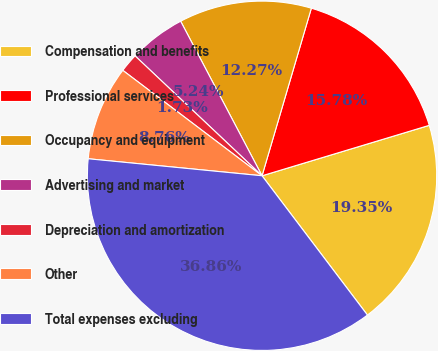Convert chart. <chart><loc_0><loc_0><loc_500><loc_500><pie_chart><fcel>Compensation and benefits<fcel>Professional services<fcel>Occupancy and equipment<fcel>Advertising and market<fcel>Depreciation and amortization<fcel>Other<fcel>Total expenses excluding<nl><fcel>19.35%<fcel>15.78%<fcel>12.27%<fcel>5.24%<fcel>1.73%<fcel>8.76%<fcel>36.86%<nl></chart> 